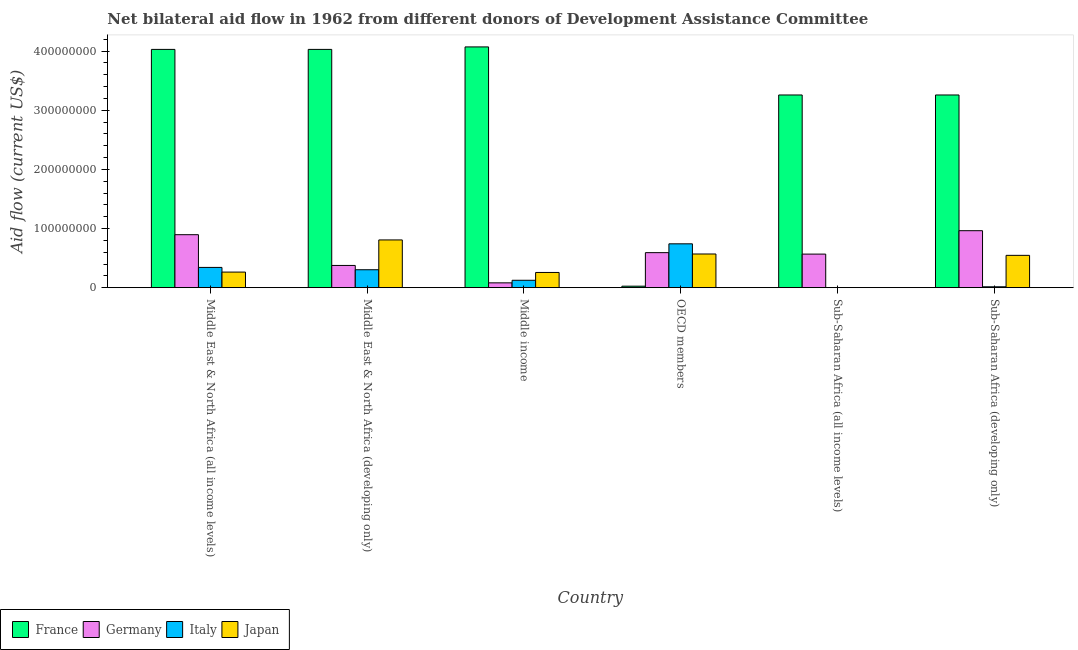Are the number of bars per tick equal to the number of legend labels?
Provide a succinct answer. No. How many bars are there on the 3rd tick from the left?
Your response must be concise. 4. What is the amount of aid given by italy in Sub-Saharan Africa (developing only)?
Your response must be concise. 1.48e+06. Across all countries, what is the maximum amount of aid given by france?
Offer a very short reply. 4.07e+08. Across all countries, what is the minimum amount of aid given by japan?
Give a very brief answer. 2.10e+05. In which country was the amount of aid given by germany maximum?
Your answer should be very brief. Sub-Saharan Africa (developing only). What is the total amount of aid given by japan in the graph?
Keep it short and to the point. 2.45e+08. What is the difference between the amount of aid given by italy in Middle East & North Africa (all income levels) and that in Sub-Saharan Africa (developing only)?
Give a very brief answer. 3.28e+07. What is the difference between the amount of aid given by italy in Middle East & North Africa (developing only) and the amount of aid given by france in Middle East & North Africa (all income levels)?
Your answer should be very brief. -3.73e+08. What is the average amount of aid given by japan per country?
Your answer should be very brief. 4.08e+07. What is the difference between the amount of aid given by italy and amount of aid given by japan in Middle East & North Africa (all income levels)?
Keep it short and to the point. 7.89e+06. Is the difference between the amount of aid given by italy in Middle income and OECD members greater than the difference between the amount of aid given by germany in Middle income and OECD members?
Provide a short and direct response. No. What is the difference between the highest and the second highest amount of aid given by japan?
Give a very brief answer. 2.38e+07. What is the difference between the highest and the lowest amount of aid given by italy?
Your answer should be very brief. 7.42e+07. Is it the case that in every country, the sum of the amount of aid given by france and amount of aid given by germany is greater than the amount of aid given by italy?
Provide a succinct answer. No. Are all the bars in the graph horizontal?
Provide a short and direct response. No. How many countries are there in the graph?
Provide a short and direct response. 6. What is the difference between two consecutive major ticks on the Y-axis?
Ensure brevity in your answer.  1.00e+08. Does the graph contain grids?
Your response must be concise. No. Where does the legend appear in the graph?
Give a very brief answer. Bottom left. How many legend labels are there?
Provide a short and direct response. 4. What is the title of the graph?
Make the answer very short. Net bilateral aid flow in 1962 from different donors of Development Assistance Committee. What is the Aid flow (current US$) of France in Middle East & North Africa (all income levels)?
Provide a succinct answer. 4.03e+08. What is the Aid flow (current US$) in Germany in Middle East & North Africa (all income levels)?
Your answer should be very brief. 8.96e+07. What is the Aid flow (current US$) in Italy in Middle East & North Africa (all income levels)?
Keep it short and to the point. 3.42e+07. What is the Aid flow (current US$) of Japan in Middle East & North Africa (all income levels)?
Your response must be concise. 2.64e+07. What is the Aid flow (current US$) of France in Middle East & North Africa (developing only)?
Your answer should be very brief. 4.03e+08. What is the Aid flow (current US$) of Germany in Middle East & North Africa (developing only)?
Provide a succinct answer. 3.76e+07. What is the Aid flow (current US$) in Italy in Middle East & North Africa (developing only)?
Offer a very short reply. 3.03e+07. What is the Aid flow (current US$) of Japan in Middle East & North Africa (developing only)?
Offer a terse response. 8.07e+07. What is the Aid flow (current US$) in France in Middle income?
Ensure brevity in your answer.  4.07e+08. What is the Aid flow (current US$) in Germany in Middle income?
Keep it short and to the point. 8.13e+06. What is the Aid flow (current US$) of Italy in Middle income?
Keep it short and to the point. 1.25e+07. What is the Aid flow (current US$) of Japan in Middle income?
Provide a succinct answer. 2.57e+07. What is the Aid flow (current US$) in France in OECD members?
Your answer should be compact. 2.50e+06. What is the Aid flow (current US$) in Germany in OECD members?
Make the answer very short. 5.92e+07. What is the Aid flow (current US$) of Italy in OECD members?
Keep it short and to the point. 7.42e+07. What is the Aid flow (current US$) in Japan in OECD members?
Offer a terse response. 5.69e+07. What is the Aid flow (current US$) of France in Sub-Saharan Africa (all income levels)?
Make the answer very short. 3.26e+08. What is the Aid flow (current US$) in Germany in Sub-Saharan Africa (all income levels)?
Provide a succinct answer. 5.68e+07. What is the Aid flow (current US$) of France in Sub-Saharan Africa (developing only)?
Offer a terse response. 3.26e+08. What is the Aid flow (current US$) of Germany in Sub-Saharan Africa (developing only)?
Provide a succinct answer. 9.64e+07. What is the Aid flow (current US$) of Italy in Sub-Saharan Africa (developing only)?
Provide a short and direct response. 1.48e+06. What is the Aid flow (current US$) in Japan in Sub-Saharan Africa (developing only)?
Offer a very short reply. 5.47e+07. Across all countries, what is the maximum Aid flow (current US$) of France?
Provide a succinct answer. 4.07e+08. Across all countries, what is the maximum Aid flow (current US$) in Germany?
Your answer should be compact. 9.64e+07. Across all countries, what is the maximum Aid flow (current US$) in Italy?
Keep it short and to the point. 7.42e+07. Across all countries, what is the maximum Aid flow (current US$) of Japan?
Offer a terse response. 8.07e+07. Across all countries, what is the minimum Aid flow (current US$) of France?
Your answer should be very brief. 2.50e+06. Across all countries, what is the minimum Aid flow (current US$) in Germany?
Your response must be concise. 8.13e+06. Across all countries, what is the minimum Aid flow (current US$) in Italy?
Offer a very short reply. 0. What is the total Aid flow (current US$) of France in the graph?
Provide a short and direct response. 1.87e+09. What is the total Aid flow (current US$) of Germany in the graph?
Your answer should be compact. 3.48e+08. What is the total Aid flow (current US$) in Italy in the graph?
Provide a succinct answer. 1.53e+08. What is the total Aid flow (current US$) in Japan in the graph?
Provide a short and direct response. 2.45e+08. What is the difference between the Aid flow (current US$) of Germany in Middle East & North Africa (all income levels) and that in Middle East & North Africa (developing only)?
Provide a succinct answer. 5.20e+07. What is the difference between the Aid flow (current US$) in Italy in Middle East & North Africa (all income levels) and that in Middle East & North Africa (developing only)?
Give a very brief answer. 3.92e+06. What is the difference between the Aid flow (current US$) of Japan in Middle East & North Africa (all income levels) and that in Middle East & North Africa (developing only)?
Offer a terse response. -5.44e+07. What is the difference between the Aid flow (current US$) of France in Middle East & North Africa (all income levels) and that in Middle income?
Offer a very short reply. -4.20e+06. What is the difference between the Aid flow (current US$) in Germany in Middle East & North Africa (all income levels) and that in Middle income?
Make the answer very short. 8.14e+07. What is the difference between the Aid flow (current US$) in Italy in Middle East & North Africa (all income levels) and that in Middle income?
Your answer should be very brief. 2.17e+07. What is the difference between the Aid flow (current US$) of Japan in Middle East & North Africa (all income levels) and that in Middle income?
Your answer should be very brief. 6.30e+05. What is the difference between the Aid flow (current US$) in France in Middle East & North Africa (all income levels) and that in OECD members?
Provide a succinct answer. 4.00e+08. What is the difference between the Aid flow (current US$) of Germany in Middle East & North Africa (all income levels) and that in OECD members?
Provide a short and direct response. 3.04e+07. What is the difference between the Aid flow (current US$) of Italy in Middle East & North Africa (all income levels) and that in OECD members?
Your answer should be very brief. -3.99e+07. What is the difference between the Aid flow (current US$) in Japan in Middle East & North Africa (all income levels) and that in OECD members?
Keep it short and to the point. -3.06e+07. What is the difference between the Aid flow (current US$) of France in Middle East & North Africa (all income levels) and that in Sub-Saharan Africa (all income levels)?
Provide a short and direct response. 7.71e+07. What is the difference between the Aid flow (current US$) of Germany in Middle East & North Africa (all income levels) and that in Sub-Saharan Africa (all income levels)?
Provide a succinct answer. 3.28e+07. What is the difference between the Aid flow (current US$) in Japan in Middle East & North Africa (all income levels) and that in Sub-Saharan Africa (all income levels)?
Make the answer very short. 2.61e+07. What is the difference between the Aid flow (current US$) in France in Middle East & North Africa (all income levels) and that in Sub-Saharan Africa (developing only)?
Keep it short and to the point. 7.71e+07. What is the difference between the Aid flow (current US$) in Germany in Middle East & North Africa (all income levels) and that in Sub-Saharan Africa (developing only)?
Provide a succinct answer. -6.78e+06. What is the difference between the Aid flow (current US$) in Italy in Middle East & North Africa (all income levels) and that in Sub-Saharan Africa (developing only)?
Ensure brevity in your answer.  3.28e+07. What is the difference between the Aid flow (current US$) of Japan in Middle East & North Africa (all income levels) and that in Sub-Saharan Africa (developing only)?
Provide a succinct answer. -2.83e+07. What is the difference between the Aid flow (current US$) of France in Middle East & North Africa (developing only) and that in Middle income?
Your response must be concise. -4.20e+06. What is the difference between the Aid flow (current US$) of Germany in Middle East & North Africa (developing only) and that in Middle income?
Provide a short and direct response. 2.95e+07. What is the difference between the Aid flow (current US$) of Italy in Middle East & North Africa (developing only) and that in Middle income?
Provide a succinct answer. 1.78e+07. What is the difference between the Aid flow (current US$) of Japan in Middle East & North Africa (developing only) and that in Middle income?
Your response must be concise. 5.50e+07. What is the difference between the Aid flow (current US$) of France in Middle East & North Africa (developing only) and that in OECD members?
Your response must be concise. 4.00e+08. What is the difference between the Aid flow (current US$) in Germany in Middle East & North Africa (developing only) and that in OECD members?
Offer a very short reply. -2.16e+07. What is the difference between the Aid flow (current US$) of Italy in Middle East & North Africa (developing only) and that in OECD members?
Your answer should be very brief. -4.38e+07. What is the difference between the Aid flow (current US$) of Japan in Middle East & North Africa (developing only) and that in OECD members?
Your answer should be very brief. 2.38e+07. What is the difference between the Aid flow (current US$) in France in Middle East & North Africa (developing only) and that in Sub-Saharan Africa (all income levels)?
Keep it short and to the point. 7.71e+07. What is the difference between the Aid flow (current US$) of Germany in Middle East & North Africa (developing only) and that in Sub-Saharan Africa (all income levels)?
Offer a terse response. -1.92e+07. What is the difference between the Aid flow (current US$) of Japan in Middle East & North Africa (developing only) and that in Sub-Saharan Africa (all income levels)?
Keep it short and to the point. 8.05e+07. What is the difference between the Aid flow (current US$) of France in Middle East & North Africa (developing only) and that in Sub-Saharan Africa (developing only)?
Your response must be concise. 7.71e+07. What is the difference between the Aid flow (current US$) of Germany in Middle East & North Africa (developing only) and that in Sub-Saharan Africa (developing only)?
Offer a very short reply. -5.88e+07. What is the difference between the Aid flow (current US$) in Italy in Middle East & North Africa (developing only) and that in Sub-Saharan Africa (developing only)?
Ensure brevity in your answer.  2.88e+07. What is the difference between the Aid flow (current US$) in Japan in Middle East & North Africa (developing only) and that in Sub-Saharan Africa (developing only)?
Make the answer very short. 2.61e+07. What is the difference between the Aid flow (current US$) in France in Middle income and that in OECD members?
Your answer should be compact. 4.05e+08. What is the difference between the Aid flow (current US$) of Germany in Middle income and that in OECD members?
Provide a short and direct response. -5.11e+07. What is the difference between the Aid flow (current US$) of Italy in Middle income and that in OECD members?
Make the answer very short. -6.16e+07. What is the difference between the Aid flow (current US$) of Japan in Middle income and that in OECD members?
Offer a very short reply. -3.12e+07. What is the difference between the Aid flow (current US$) in France in Middle income and that in Sub-Saharan Africa (all income levels)?
Offer a terse response. 8.13e+07. What is the difference between the Aid flow (current US$) in Germany in Middle income and that in Sub-Saharan Africa (all income levels)?
Provide a short and direct response. -4.86e+07. What is the difference between the Aid flow (current US$) of Japan in Middle income and that in Sub-Saharan Africa (all income levels)?
Your response must be concise. 2.55e+07. What is the difference between the Aid flow (current US$) of France in Middle income and that in Sub-Saharan Africa (developing only)?
Offer a terse response. 8.13e+07. What is the difference between the Aid flow (current US$) of Germany in Middle income and that in Sub-Saharan Africa (developing only)?
Offer a very short reply. -8.82e+07. What is the difference between the Aid flow (current US$) of Italy in Middle income and that in Sub-Saharan Africa (developing only)?
Make the answer very short. 1.10e+07. What is the difference between the Aid flow (current US$) in Japan in Middle income and that in Sub-Saharan Africa (developing only)?
Offer a very short reply. -2.89e+07. What is the difference between the Aid flow (current US$) in France in OECD members and that in Sub-Saharan Africa (all income levels)?
Offer a very short reply. -3.23e+08. What is the difference between the Aid flow (current US$) in Germany in OECD members and that in Sub-Saharan Africa (all income levels)?
Give a very brief answer. 2.45e+06. What is the difference between the Aid flow (current US$) in Japan in OECD members and that in Sub-Saharan Africa (all income levels)?
Your response must be concise. 5.67e+07. What is the difference between the Aid flow (current US$) in France in OECD members and that in Sub-Saharan Africa (developing only)?
Offer a very short reply. -3.23e+08. What is the difference between the Aid flow (current US$) in Germany in OECD members and that in Sub-Saharan Africa (developing only)?
Ensure brevity in your answer.  -3.71e+07. What is the difference between the Aid flow (current US$) of Italy in OECD members and that in Sub-Saharan Africa (developing only)?
Provide a short and direct response. 7.27e+07. What is the difference between the Aid flow (current US$) in Japan in OECD members and that in Sub-Saharan Africa (developing only)?
Your answer should be compact. 2.28e+06. What is the difference between the Aid flow (current US$) of France in Sub-Saharan Africa (all income levels) and that in Sub-Saharan Africa (developing only)?
Ensure brevity in your answer.  0. What is the difference between the Aid flow (current US$) in Germany in Sub-Saharan Africa (all income levels) and that in Sub-Saharan Africa (developing only)?
Offer a terse response. -3.96e+07. What is the difference between the Aid flow (current US$) of Japan in Sub-Saharan Africa (all income levels) and that in Sub-Saharan Africa (developing only)?
Make the answer very short. -5.44e+07. What is the difference between the Aid flow (current US$) of France in Middle East & North Africa (all income levels) and the Aid flow (current US$) of Germany in Middle East & North Africa (developing only)?
Your response must be concise. 3.65e+08. What is the difference between the Aid flow (current US$) of France in Middle East & North Africa (all income levels) and the Aid flow (current US$) of Italy in Middle East & North Africa (developing only)?
Your response must be concise. 3.73e+08. What is the difference between the Aid flow (current US$) in France in Middle East & North Africa (all income levels) and the Aid flow (current US$) in Japan in Middle East & North Africa (developing only)?
Make the answer very short. 3.22e+08. What is the difference between the Aid flow (current US$) in Germany in Middle East & North Africa (all income levels) and the Aid flow (current US$) in Italy in Middle East & North Africa (developing only)?
Your answer should be compact. 5.93e+07. What is the difference between the Aid flow (current US$) of Germany in Middle East & North Africa (all income levels) and the Aid flow (current US$) of Japan in Middle East & North Africa (developing only)?
Give a very brief answer. 8.85e+06. What is the difference between the Aid flow (current US$) in Italy in Middle East & North Africa (all income levels) and the Aid flow (current US$) in Japan in Middle East & North Africa (developing only)?
Provide a short and direct response. -4.65e+07. What is the difference between the Aid flow (current US$) in France in Middle East & North Africa (all income levels) and the Aid flow (current US$) in Germany in Middle income?
Ensure brevity in your answer.  3.95e+08. What is the difference between the Aid flow (current US$) in France in Middle East & North Africa (all income levels) and the Aid flow (current US$) in Italy in Middle income?
Keep it short and to the point. 3.90e+08. What is the difference between the Aid flow (current US$) in France in Middle East & North Africa (all income levels) and the Aid flow (current US$) in Japan in Middle income?
Your answer should be very brief. 3.77e+08. What is the difference between the Aid flow (current US$) in Germany in Middle East & North Africa (all income levels) and the Aid flow (current US$) in Italy in Middle income?
Provide a short and direct response. 7.71e+07. What is the difference between the Aid flow (current US$) in Germany in Middle East & North Africa (all income levels) and the Aid flow (current US$) in Japan in Middle income?
Provide a short and direct response. 6.39e+07. What is the difference between the Aid flow (current US$) of Italy in Middle East & North Africa (all income levels) and the Aid flow (current US$) of Japan in Middle income?
Offer a very short reply. 8.52e+06. What is the difference between the Aid flow (current US$) in France in Middle East & North Africa (all income levels) and the Aid flow (current US$) in Germany in OECD members?
Your response must be concise. 3.44e+08. What is the difference between the Aid flow (current US$) in France in Middle East & North Africa (all income levels) and the Aid flow (current US$) in Italy in OECD members?
Your answer should be very brief. 3.29e+08. What is the difference between the Aid flow (current US$) in France in Middle East & North Africa (all income levels) and the Aid flow (current US$) in Japan in OECD members?
Ensure brevity in your answer.  3.46e+08. What is the difference between the Aid flow (current US$) in Germany in Middle East & North Africa (all income levels) and the Aid flow (current US$) in Italy in OECD members?
Offer a terse response. 1.54e+07. What is the difference between the Aid flow (current US$) of Germany in Middle East & North Africa (all income levels) and the Aid flow (current US$) of Japan in OECD members?
Provide a succinct answer. 3.26e+07. What is the difference between the Aid flow (current US$) of Italy in Middle East & North Africa (all income levels) and the Aid flow (current US$) of Japan in OECD members?
Keep it short and to the point. -2.27e+07. What is the difference between the Aid flow (current US$) in France in Middle East & North Africa (all income levels) and the Aid flow (current US$) in Germany in Sub-Saharan Africa (all income levels)?
Make the answer very short. 3.46e+08. What is the difference between the Aid flow (current US$) of France in Middle East & North Africa (all income levels) and the Aid flow (current US$) of Japan in Sub-Saharan Africa (all income levels)?
Your response must be concise. 4.03e+08. What is the difference between the Aid flow (current US$) of Germany in Middle East & North Africa (all income levels) and the Aid flow (current US$) of Japan in Sub-Saharan Africa (all income levels)?
Provide a short and direct response. 8.94e+07. What is the difference between the Aid flow (current US$) in Italy in Middle East & North Africa (all income levels) and the Aid flow (current US$) in Japan in Sub-Saharan Africa (all income levels)?
Make the answer very short. 3.40e+07. What is the difference between the Aid flow (current US$) in France in Middle East & North Africa (all income levels) and the Aid flow (current US$) in Germany in Sub-Saharan Africa (developing only)?
Ensure brevity in your answer.  3.07e+08. What is the difference between the Aid flow (current US$) in France in Middle East & North Africa (all income levels) and the Aid flow (current US$) in Italy in Sub-Saharan Africa (developing only)?
Provide a succinct answer. 4.02e+08. What is the difference between the Aid flow (current US$) of France in Middle East & North Africa (all income levels) and the Aid flow (current US$) of Japan in Sub-Saharan Africa (developing only)?
Give a very brief answer. 3.48e+08. What is the difference between the Aid flow (current US$) of Germany in Middle East & North Africa (all income levels) and the Aid flow (current US$) of Italy in Sub-Saharan Africa (developing only)?
Keep it short and to the point. 8.81e+07. What is the difference between the Aid flow (current US$) in Germany in Middle East & North Africa (all income levels) and the Aid flow (current US$) in Japan in Sub-Saharan Africa (developing only)?
Offer a very short reply. 3.49e+07. What is the difference between the Aid flow (current US$) in Italy in Middle East & North Africa (all income levels) and the Aid flow (current US$) in Japan in Sub-Saharan Africa (developing only)?
Provide a short and direct response. -2.04e+07. What is the difference between the Aid flow (current US$) of France in Middle East & North Africa (developing only) and the Aid flow (current US$) of Germany in Middle income?
Offer a terse response. 3.95e+08. What is the difference between the Aid flow (current US$) in France in Middle East & North Africa (developing only) and the Aid flow (current US$) in Italy in Middle income?
Offer a very short reply. 3.90e+08. What is the difference between the Aid flow (current US$) of France in Middle East & North Africa (developing only) and the Aid flow (current US$) of Japan in Middle income?
Give a very brief answer. 3.77e+08. What is the difference between the Aid flow (current US$) in Germany in Middle East & North Africa (developing only) and the Aid flow (current US$) in Italy in Middle income?
Give a very brief answer. 2.51e+07. What is the difference between the Aid flow (current US$) of Germany in Middle East & North Africa (developing only) and the Aid flow (current US$) of Japan in Middle income?
Your answer should be compact. 1.19e+07. What is the difference between the Aid flow (current US$) in Italy in Middle East & North Africa (developing only) and the Aid flow (current US$) in Japan in Middle income?
Your answer should be compact. 4.60e+06. What is the difference between the Aid flow (current US$) of France in Middle East & North Africa (developing only) and the Aid flow (current US$) of Germany in OECD members?
Your response must be concise. 3.44e+08. What is the difference between the Aid flow (current US$) of France in Middle East & North Africa (developing only) and the Aid flow (current US$) of Italy in OECD members?
Make the answer very short. 3.29e+08. What is the difference between the Aid flow (current US$) in France in Middle East & North Africa (developing only) and the Aid flow (current US$) in Japan in OECD members?
Provide a short and direct response. 3.46e+08. What is the difference between the Aid flow (current US$) in Germany in Middle East & North Africa (developing only) and the Aid flow (current US$) in Italy in OECD members?
Ensure brevity in your answer.  -3.66e+07. What is the difference between the Aid flow (current US$) of Germany in Middle East & North Africa (developing only) and the Aid flow (current US$) of Japan in OECD members?
Provide a succinct answer. -1.94e+07. What is the difference between the Aid flow (current US$) in Italy in Middle East & North Africa (developing only) and the Aid flow (current US$) in Japan in OECD members?
Offer a terse response. -2.66e+07. What is the difference between the Aid flow (current US$) of France in Middle East & North Africa (developing only) and the Aid flow (current US$) of Germany in Sub-Saharan Africa (all income levels)?
Provide a short and direct response. 3.46e+08. What is the difference between the Aid flow (current US$) in France in Middle East & North Africa (developing only) and the Aid flow (current US$) in Japan in Sub-Saharan Africa (all income levels)?
Offer a very short reply. 4.03e+08. What is the difference between the Aid flow (current US$) in Germany in Middle East & North Africa (developing only) and the Aid flow (current US$) in Japan in Sub-Saharan Africa (all income levels)?
Provide a short and direct response. 3.74e+07. What is the difference between the Aid flow (current US$) of Italy in Middle East & North Africa (developing only) and the Aid flow (current US$) of Japan in Sub-Saharan Africa (all income levels)?
Your response must be concise. 3.01e+07. What is the difference between the Aid flow (current US$) of France in Middle East & North Africa (developing only) and the Aid flow (current US$) of Germany in Sub-Saharan Africa (developing only)?
Make the answer very short. 3.07e+08. What is the difference between the Aid flow (current US$) of France in Middle East & North Africa (developing only) and the Aid flow (current US$) of Italy in Sub-Saharan Africa (developing only)?
Make the answer very short. 4.02e+08. What is the difference between the Aid flow (current US$) in France in Middle East & North Africa (developing only) and the Aid flow (current US$) in Japan in Sub-Saharan Africa (developing only)?
Give a very brief answer. 3.48e+08. What is the difference between the Aid flow (current US$) of Germany in Middle East & North Africa (developing only) and the Aid flow (current US$) of Italy in Sub-Saharan Africa (developing only)?
Your response must be concise. 3.61e+07. What is the difference between the Aid flow (current US$) of Germany in Middle East & North Africa (developing only) and the Aid flow (current US$) of Japan in Sub-Saharan Africa (developing only)?
Provide a succinct answer. -1.71e+07. What is the difference between the Aid flow (current US$) in Italy in Middle East & North Africa (developing only) and the Aid flow (current US$) in Japan in Sub-Saharan Africa (developing only)?
Make the answer very short. -2.43e+07. What is the difference between the Aid flow (current US$) in France in Middle income and the Aid flow (current US$) in Germany in OECD members?
Provide a succinct answer. 3.48e+08. What is the difference between the Aid flow (current US$) of France in Middle income and the Aid flow (current US$) of Italy in OECD members?
Keep it short and to the point. 3.33e+08. What is the difference between the Aid flow (current US$) in France in Middle income and the Aid flow (current US$) in Japan in OECD members?
Give a very brief answer. 3.50e+08. What is the difference between the Aid flow (current US$) in Germany in Middle income and the Aid flow (current US$) in Italy in OECD members?
Provide a succinct answer. -6.60e+07. What is the difference between the Aid flow (current US$) in Germany in Middle income and the Aid flow (current US$) in Japan in OECD members?
Provide a short and direct response. -4.88e+07. What is the difference between the Aid flow (current US$) in Italy in Middle income and the Aid flow (current US$) in Japan in OECD members?
Offer a terse response. -4.44e+07. What is the difference between the Aid flow (current US$) of France in Middle income and the Aid flow (current US$) of Germany in Sub-Saharan Africa (all income levels)?
Ensure brevity in your answer.  3.50e+08. What is the difference between the Aid flow (current US$) of France in Middle income and the Aid flow (current US$) of Japan in Sub-Saharan Africa (all income levels)?
Offer a very short reply. 4.07e+08. What is the difference between the Aid flow (current US$) in Germany in Middle income and the Aid flow (current US$) in Japan in Sub-Saharan Africa (all income levels)?
Give a very brief answer. 7.92e+06. What is the difference between the Aid flow (current US$) in Italy in Middle income and the Aid flow (current US$) in Japan in Sub-Saharan Africa (all income levels)?
Ensure brevity in your answer.  1.23e+07. What is the difference between the Aid flow (current US$) in France in Middle income and the Aid flow (current US$) in Germany in Sub-Saharan Africa (developing only)?
Ensure brevity in your answer.  3.11e+08. What is the difference between the Aid flow (current US$) in France in Middle income and the Aid flow (current US$) in Italy in Sub-Saharan Africa (developing only)?
Give a very brief answer. 4.06e+08. What is the difference between the Aid flow (current US$) of France in Middle income and the Aid flow (current US$) of Japan in Sub-Saharan Africa (developing only)?
Give a very brief answer. 3.53e+08. What is the difference between the Aid flow (current US$) of Germany in Middle income and the Aid flow (current US$) of Italy in Sub-Saharan Africa (developing only)?
Provide a short and direct response. 6.65e+06. What is the difference between the Aid flow (current US$) in Germany in Middle income and the Aid flow (current US$) in Japan in Sub-Saharan Africa (developing only)?
Provide a succinct answer. -4.65e+07. What is the difference between the Aid flow (current US$) of Italy in Middle income and the Aid flow (current US$) of Japan in Sub-Saharan Africa (developing only)?
Your response must be concise. -4.22e+07. What is the difference between the Aid flow (current US$) in France in OECD members and the Aid flow (current US$) in Germany in Sub-Saharan Africa (all income levels)?
Ensure brevity in your answer.  -5.43e+07. What is the difference between the Aid flow (current US$) in France in OECD members and the Aid flow (current US$) in Japan in Sub-Saharan Africa (all income levels)?
Provide a short and direct response. 2.29e+06. What is the difference between the Aid flow (current US$) in Germany in OECD members and the Aid flow (current US$) in Japan in Sub-Saharan Africa (all income levels)?
Ensure brevity in your answer.  5.90e+07. What is the difference between the Aid flow (current US$) in Italy in OECD members and the Aid flow (current US$) in Japan in Sub-Saharan Africa (all income levels)?
Give a very brief answer. 7.39e+07. What is the difference between the Aid flow (current US$) of France in OECD members and the Aid flow (current US$) of Germany in Sub-Saharan Africa (developing only)?
Provide a succinct answer. -9.39e+07. What is the difference between the Aid flow (current US$) in France in OECD members and the Aid flow (current US$) in Italy in Sub-Saharan Africa (developing only)?
Provide a short and direct response. 1.02e+06. What is the difference between the Aid flow (current US$) of France in OECD members and the Aid flow (current US$) of Japan in Sub-Saharan Africa (developing only)?
Make the answer very short. -5.22e+07. What is the difference between the Aid flow (current US$) in Germany in OECD members and the Aid flow (current US$) in Italy in Sub-Saharan Africa (developing only)?
Your answer should be very brief. 5.77e+07. What is the difference between the Aid flow (current US$) of Germany in OECD members and the Aid flow (current US$) of Japan in Sub-Saharan Africa (developing only)?
Offer a very short reply. 4.56e+06. What is the difference between the Aid flow (current US$) of Italy in OECD members and the Aid flow (current US$) of Japan in Sub-Saharan Africa (developing only)?
Give a very brief answer. 1.95e+07. What is the difference between the Aid flow (current US$) in France in Sub-Saharan Africa (all income levels) and the Aid flow (current US$) in Germany in Sub-Saharan Africa (developing only)?
Offer a terse response. 2.30e+08. What is the difference between the Aid flow (current US$) of France in Sub-Saharan Africa (all income levels) and the Aid flow (current US$) of Italy in Sub-Saharan Africa (developing only)?
Your answer should be compact. 3.24e+08. What is the difference between the Aid flow (current US$) of France in Sub-Saharan Africa (all income levels) and the Aid flow (current US$) of Japan in Sub-Saharan Africa (developing only)?
Ensure brevity in your answer.  2.71e+08. What is the difference between the Aid flow (current US$) in Germany in Sub-Saharan Africa (all income levels) and the Aid flow (current US$) in Italy in Sub-Saharan Africa (developing only)?
Keep it short and to the point. 5.53e+07. What is the difference between the Aid flow (current US$) of Germany in Sub-Saharan Africa (all income levels) and the Aid flow (current US$) of Japan in Sub-Saharan Africa (developing only)?
Provide a succinct answer. 2.11e+06. What is the average Aid flow (current US$) of France per country?
Offer a terse response. 3.11e+08. What is the average Aid flow (current US$) in Germany per country?
Your answer should be very brief. 5.79e+07. What is the average Aid flow (current US$) of Italy per country?
Ensure brevity in your answer.  2.54e+07. What is the average Aid flow (current US$) of Japan per country?
Make the answer very short. 4.08e+07. What is the difference between the Aid flow (current US$) of France and Aid flow (current US$) of Germany in Middle East & North Africa (all income levels)?
Give a very brief answer. 3.13e+08. What is the difference between the Aid flow (current US$) of France and Aid flow (current US$) of Italy in Middle East & North Africa (all income levels)?
Keep it short and to the point. 3.69e+08. What is the difference between the Aid flow (current US$) in France and Aid flow (current US$) in Japan in Middle East & North Africa (all income levels)?
Ensure brevity in your answer.  3.77e+08. What is the difference between the Aid flow (current US$) of Germany and Aid flow (current US$) of Italy in Middle East & North Africa (all income levels)?
Keep it short and to the point. 5.53e+07. What is the difference between the Aid flow (current US$) of Germany and Aid flow (current US$) of Japan in Middle East & North Africa (all income levels)?
Keep it short and to the point. 6.32e+07. What is the difference between the Aid flow (current US$) in Italy and Aid flow (current US$) in Japan in Middle East & North Africa (all income levels)?
Make the answer very short. 7.89e+06. What is the difference between the Aid flow (current US$) in France and Aid flow (current US$) in Germany in Middle East & North Africa (developing only)?
Give a very brief answer. 3.65e+08. What is the difference between the Aid flow (current US$) in France and Aid flow (current US$) in Italy in Middle East & North Africa (developing only)?
Provide a short and direct response. 3.73e+08. What is the difference between the Aid flow (current US$) of France and Aid flow (current US$) of Japan in Middle East & North Africa (developing only)?
Your answer should be very brief. 3.22e+08. What is the difference between the Aid flow (current US$) in Germany and Aid flow (current US$) in Italy in Middle East & North Africa (developing only)?
Offer a very short reply. 7.27e+06. What is the difference between the Aid flow (current US$) in Germany and Aid flow (current US$) in Japan in Middle East & North Africa (developing only)?
Provide a short and direct response. -4.31e+07. What is the difference between the Aid flow (current US$) in Italy and Aid flow (current US$) in Japan in Middle East & North Africa (developing only)?
Your answer should be compact. -5.04e+07. What is the difference between the Aid flow (current US$) in France and Aid flow (current US$) in Germany in Middle income?
Ensure brevity in your answer.  3.99e+08. What is the difference between the Aid flow (current US$) in France and Aid flow (current US$) in Italy in Middle income?
Make the answer very short. 3.95e+08. What is the difference between the Aid flow (current US$) of France and Aid flow (current US$) of Japan in Middle income?
Provide a succinct answer. 3.81e+08. What is the difference between the Aid flow (current US$) in Germany and Aid flow (current US$) in Italy in Middle income?
Offer a very short reply. -4.37e+06. What is the difference between the Aid flow (current US$) in Germany and Aid flow (current US$) in Japan in Middle income?
Offer a very short reply. -1.76e+07. What is the difference between the Aid flow (current US$) of Italy and Aid flow (current US$) of Japan in Middle income?
Your answer should be compact. -1.32e+07. What is the difference between the Aid flow (current US$) in France and Aid flow (current US$) in Germany in OECD members?
Ensure brevity in your answer.  -5.67e+07. What is the difference between the Aid flow (current US$) in France and Aid flow (current US$) in Italy in OECD members?
Provide a succinct answer. -7.16e+07. What is the difference between the Aid flow (current US$) in France and Aid flow (current US$) in Japan in OECD members?
Offer a very short reply. -5.44e+07. What is the difference between the Aid flow (current US$) in Germany and Aid flow (current US$) in Italy in OECD members?
Give a very brief answer. -1.49e+07. What is the difference between the Aid flow (current US$) in Germany and Aid flow (current US$) in Japan in OECD members?
Make the answer very short. 2.28e+06. What is the difference between the Aid flow (current US$) of Italy and Aid flow (current US$) of Japan in OECD members?
Offer a very short reply. 1.72e+07. What is the difference between the Aid flow (current US$) in France and Aid flow (current US$) in Germany in Sub-Saharan Africa (all income levels)?
Provide a short and direct response. 2.69e+08. What is the difference between the Aid flow (current US$) in France and Aid flow (current US$) in Japan in Sub-Saharan Africa (all income levels)?
Provide a short and direct response. 3.26e+08. What is the difference between the Aid flow (current US$) of Germany and Aid flow (current US$) of Japan in Sub-Saharan Africa (all income levels)?
Your answer should be very brief. 5.66e+07. What is the difference between the Aid flow (current US$) of France and Aid flow (current US$) of Germany in Sub-Saharan Africa (developing only)?
Your answer should be compact. 2.30e+08. What is the difference between the Aid flow (current US$) in France and Aid flow (current US$) in Italy in Sub-Saharan Africa (developing only)?
Provide a succinct answer. 3.24e+08. What is the difference between the Aid flow (current US$) in France and Aid flow (current US$) in Japan in Sub-Saharan Africa (developing only)?
Provide a succinct answer. 2.71e+08. What is the difference between the Aid flow (current US$) in Germany and Aid flow (current US$) in Italy in Sub-Saharan Africa (developing only)?
Your answer should be compact. 9.49e+07. What is the difference between the Aid flow (current US$) of Germany and Aid flow (current US$) of Japan in Sub-Saharan Africa (developing only)?
Your answer should be very brief. 4.17e+07. What is the difference between the Aid flow (current US$) in Italy and Aid flow (current US$) in Japan in Sub-Saharan Africa (developing only)?
Offer a terse response. -5.32e+07. What is the ratio of the Aid flow (current US$) in Germany in Middle East & North Africa (all income levels) to that in Middle East & North Africa (developing only)?
Provide a short and direct response. 2.38. What is the ratio of the Aid flow (current US$) of Italy in Middle East & North Africa (all income levels) to that in Middle East & North Africa (developing only)?
Make the answer very short. 1.13. What is the ratio of the Aid flow (current US$) in Japan in Middle East & North Africa (all income levels) to that in Middle East & North Africa (developing only)?
Provide a short and direct response. 0.33. What is the ratio of the Aid flow (current US$) of Germany in Middle East & North Africa (all income levels) to that in Middle income?
Offer a very short reply. 11.02. What is the ratio of the Aid flow (current US$) in Italy in Middle East & North Africa (all income levels) to that in Middle income?
Your answer should be very brief. 2.74. What is the ratio of the Aid flow (current US$) of Japan in Middle East & North Africa (all income levels) to that in Middle income?
Your answer should be compact. 1.02. What is the ratio of the Aid flow (current US$) in France in Middle East & North Africa (all income levels) to that in OECD members?
Keep it short and to the point. 161.2. What is the ratio of the Aid flow (current US$) of Germany in Middle East & North Africa (all income levels) to that in OECD members?
Offer a terse response. 1.51. What is the ratio of the Aid flow (current US$) of Italy in Middle East & North Africa (all income levels) to that in OECD members?
Offer a very short reply. 0.46. What is the ratio of the Aid flow (current US$) of Japan in Middle East & North Africa (all income levels) to that in OECD members?
Give a very brief answer. 0.46. What is the ratio of the Aid flow (current US$) of France in Middle East & North Africa (all income levels) to that in Sub-Saharan Africa (all income levels)?
Offer a terse response. 1.24. What is the ratio of the Aid flow (current US$) of Germany in Middle East & North Africa (all income levels) to that in Sub-Saharan Africa (all income levels)?
Offer a terse response. 1.58. What is the ratio of the Aid flow (current US$) in Japan in Middle East & North Africa (all income levels) to that in Sub-Saharan Africa (all income levels)?
Keep it short and to the point. 125.48. What is the ratio of the Aid flow (current US$) in France in Middle East & North Africa (all income levels) to that in Sub-Saharan Africa (developing only)?
Your response must be concise. 1.24. What is the ratio of the Aid flow (current US$) of Germany in Middle East & North Africa (all income levels) to that in Sub-Saharan Africa (developing only)?
Offer a terse response. 0.93. What is the ratio of the Aid flow (current US$) in Italy in Middle East & North Africa (all income levels) to that in Sub-Saharan Africa (developing only)?
Provide a short and direct response. 23.14. What is the ratio of the Aid flow (current US$) in Japan in Middle East & North Africa (all income levels) to that in Sub-Saharan Africa (developing only)?
Offer a terse response. 0.48. What is the ratio of the Aid flow (current US$) in France in Middle East & North Africa (developing only) to that in Middle income?
Your answer should be compact. 0.99. What is the ratio of the Aid flow (current US$) of Germany in Middle East & North Africa (developing only) to that in Middle income?
Give a very brief answer. 4.62. What is the ratio of the Aid flow (current US$) of Italy in Middle East & North Africa (developing only) to that in Middle income?
Offer a very short reply. 2.43. What is the ratio of the Aid flow (current US$) in Japan in Middle East & North Africa (developing only) to that in Middle income?
Your answer should be compact. 3.14. What is the ratio of the Aid flow (current US$) in France in Middle East & North Africa (developing only) to that in OECD members?
Offer a terse response. 161.2. What is the ratio of the Aid flow (current US$) in Germany in Middle East & North Africa (developing only) to that in OECD members?
Offer a terse response. 0.63. What is the ratio of the Aid flow (current US$) in Italy in Middle East & North Africa (developing only) to that in OECD members?
Your answer should be very brief. 0.41. What is the ratio of the Aid flow (current US$) in Japan in Middle East & North Africa (developing only) to that in OECD members?
Offer a very short reply. 1.42. What is the ratio of the Aid flow (current US$) of France in Middle East & North Africa (developing only) to that in Sub-Saharan Africa (all income levels)?
Give a very brief answer. 1.24. What is the ratio of the Aid flow (current US$) of Germany in Middle East & North Africa (developing only) to that in Sub-Saharan Africa (all income levels)?
Offer a very short reply. 0.66. What is the ratio of the Aid flow (current US$) in Japan in Middle East & North Africa (developing only) to that in Sub-Saharan Africa (all income levels)?
Offer a very short reply. 384.43. What is the ratio of the Aid flow (current US$) in France in Middle East & North Africa (developing only) to that in Sub-Saharan Africa (developing only)?
Provide a short and direct response. 1.24. What is the ratio of the Aid flow (current US$) of Germany in Middle East & North Africa (developing only) to that in Sub-Saharan Africa (developing only)?
Provide a succinct answer. 0.39. What is the ratio of the Aid flow (current US$) in Italy in Middle East & North Africa (developing only) to that in Sub-Saharan Africa (developing only)?
Give a very brief answer. 20.49. What is the ratio of the Aid flow (current US$) in Japan in Middle East & North Africa (developing only) to that in Sub-Saharan Africa (developing only)?
Offer a terse response. 1.48. What is the ratio of the Aid flow (current US$) of France in Middle income to that in OECD members?
Keep it short and to the point. 162.88. What is the ratio of the Aid flow (current US$) in Germany in Middle income to that in OECD members?
Provide a short and direct response. 0.14. What is the ratio of the Aid flow (current US$) in Italy in Middle income to that in OECD members?
Keep it short and to the point. 0.17. What is the ratio of the Aid flow (current US$) of Japan in Middle income to that in OECD members?
Offer a very short reply. 0.45. What is the ratio of the Aid flow (current US$) in France in Middle income to that in Sub-Saharan Africa (all income levels)?
Your response must be concise. 1.25. What is the ratio of the Aid flow (current US$) of Germany in Middle income to that in Sub-Saharan Africa (all income levels)?
Provide a succinct answer. 0.14. What is the ratio of the Aid flow (current US$) in Japan in Middle income to that in Sub-Saharan Africa (all income levels)?
Provide a short and direct response. 122.48. What is the ratio of the Aid flow (current US$) in France in Middle income to that in Sub-Saharan Africa (developing only)?
Provide a short and direct response. 1.25. What is the ratio of the Aid flow (current US$) in Germany in Middle income to that in Sub-Saharan Africa (developing only)?
Offer a terse response. 0.08. What is the ratio of the Aid flow (current US$) of Italy in Middle income to that in Sub-Saharan Africa (developing only)?
Ensure brevity in your answer.  8.45. What is the ratio of the Aid flow (current US$) in Japan in Middle income to that in Sub-Saharan Africa (developing only)?
Your answer should be very brief. 0.47. What is the ratio of the Aid flow (current US$) of France in OECD members to that in Sub-Saharan Africa (all income levels)?
Your answer should be compact. 0.01. What is the ratio of the Aid flow (current US$) of Germany in OECD members to that in Sub-Saharan Africa (all income levels)?
Give a very brief answer. 1.04. What is the ratio of the Aid flow (current US$) of Japan in OECD members to that in Sub-Saharan Africa (all income levels)?
Ensure brevity in your answer.  271.14. What is the ratio of the Aid flow (current US$) of France in OECD members to that in Sub-Saharan Africa (developing only)?
Provide a succinct answer. 0.01. What is the ratio of the Aid flow (current US$) of Germany in OECD members to that in Sub-Saharan Africa (developing only)?
Keep it short and to the point. 0.61. What is the ratio of the Aid flow (current US$) in Italy in OECD members to that in Sub-Saharan Africa (developing only)?
Give a very brief answer. 50.1. What is the ratio of the Aid flow (current US$) in Japan in OECD members to that in Sub-Saharan Africa (developing only)?
Offer a terse response. 1.04. What is the ratio of the Aid flow (current US$) of Germany in Sub-Saharan Africa (all income levels) to that in Sub-Saharan Africa (developing only)?
Offer a very short reply. 0.59. What is the ratio of the Aid flow (current US$) in Japan in Sub-Saharan Africa (all income levels) to that in Sub-Saharan Africa (developing only)?
Provide a short and direct response. 0. What is the difference between the highest and the second highest Aid flow (current US$) of France?
Keep it short and to the point. 4.20e+06. What is the difference between the highest and the second highest Aid flow (current US$) in Germany?
Provide a short and direct response. 6.78e+06. What is the difference between the highest and the second highest Aid flow (current US$) in Italy?
Provide a succinct answer. 3.99e+07. What is the difference between the highest and the second highest Aid flow (current US$) of Japan?
Your response must be concise. 2.38e+07. What is the difference between the highest and the lowest Aid flow (current US$) in France?
Provide a succinct answer. 4.05e+08. What is the difference between the highest and the lowest Aid flow (current US$) of Germany?
Your answer should be compact. 8.82e+07. What is the difference between the highest and the lowest Aid flow (current US$) in Italy?
Offer a terse response. 7.42e+07. What is the difference between the highest and the lowest Aid flow (current US$) in Japan?
Offer a very short reply. 8.05e+07. 